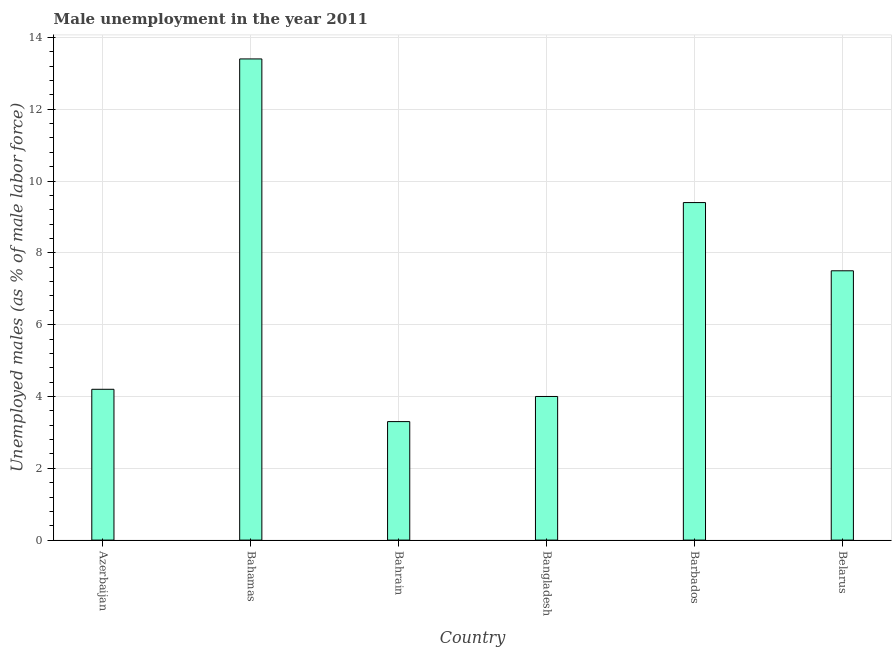What is the title of the graph?
Ensure brevity in your answer.  Male unemployment in the year 2011. What is the label or title of the X-axis?
Offer a very short reply. Country. What is the label or title of the Y-axis?
Your response must be concise. Unemployed males (as % of male labor force). What is the unemployed males population in Azerbaijan?
Keep it short and to the point. 4.2. Across all countries, what is the maximum unemployed males population?
Your response must be concise. 13.4. Across all countries, what is the minimum unemployed males population?
Provide a short and direct response. 3.3. In which country was the unemployed males population maximum?
Provide a succinct answer. Bahamas. In which country was the unemployed males population minimum?
Provide a short and direct response. Bahrain. What is the sum of the unemployed males population?
Ensure brevity in your answer.  41.8. What is the difference between the unemployed males population in Bahamas and Bangladesh?
Offer a terse response. 9.4. What is the average unemployed males population per country?
Give a very brief answer. 6.97. What is the median unemployed males population?
Give a very brief answer. 5.85. What is the ratio of the unemployed males population in Barbados to that in Belarus?
Your response must be concise. 1.25. What is the difference between the highest and the second highest unemployed males population?
Ensure brevity in your answer.  4. Are all the bars in the graph horizontal?
Provide a short and direct response. No. How many countries are there in the graph?
Offer a very short reply. 6. What is the difference between two consecutive major ticks on the Y-axis?
Your answer should be very brief. 2. What is the Unemployed males (as % of male labor force) of Azerbaijan?
Your answer should be compact. 4.2. What is the Unemployed males (as % of male labor force) in Bahamas?
Provide a succinct answer. 13.4. What is the Unemployed males (as % of male labor force) in Bahrain?
Ensure brevity in your answer.  3.3. What is the Unemployed males (as % of male labor force) of Bangladesh?
Your answer should be compact. 4. What is the Unemployed males (as % of male labor force) in Barbados?
Ensure brevity in your answer.  9.4. What is the Unemployed males (as % of male labor force) in Belarus?
Your response must be concise. 7.5. What is the difference between the Unemployed males (as % of male labor force) in Azerbaijan and Bahrain?
Provide a short and direct response. 0.9. What is the difference between the Unemployed males (as % of male labor force) in Azerbaijan and Bangladesh?
Provide a succinct answer. 0.2. What is the difference between the Unemployed males (as % of male labor force) in Bahrain and Bangladesh?
Give a very brief answer. -0.7. What is the ratio of the Unemployed males (as % of male labor force) in Azerbaijan to that in Bahamas?
Keep it short and to the point. 0.31. What is the ratio of the Unemployed males (as % of male labor force) in Azerbaijan to that in Bahrain?
Your response must be concise. 1.27. What is the ratio of the Unemployed males (as % of male labor force) in Azerbaijan to that in Bangladesh?
Make the answer very short. 1.05. What is the ratio of the Unemployed males (as % of male labor force) in Azerbaijan to that in Barbados?
Offer a very short reply. 0.45. What is the ratio of the Unemployed males (as % of male labor force) in Azerbaijan to that in Belarus?
Your answer should be very brief. 0.56. What is the ratio of the Unemployed males (as % of male labor force) in Bahamas to that in Bahrain?
Your answer should be very brief. 4.06. What is the ratio of the Unemployed males (as % of male labor force) in Bahamas to that in Bangladesh?
Your response must be concise. 3.35. What is the ratio of the Unemployed males (as % of male labor force) in Bahamas to that in Barbados?
Provide a short and direct response. 1.43. What is the ratio of the Unemployed males (as % of male labor force) in Bahamas to that in Belarus?
Offer a very short reply. 1.79. What is the ratio of the Unemployed males (as % of male labor force) in Bahrain to that in Bangladesh?
Keep it short and to the point. 0.82. What is the ratio of the Unemployed males (as % of male labor force) in Bahrain to that in Barbados?
Make the answer very short. 0.35. What is the ratio of the Unemployed males (as % of male labor force) in Bahrain to that in Belarus?
Your answer should be very brief. 0.44. What is the ratio of the Unemployed males (as % of male labor force) in Bangladesh to that in Barbados?
Provide a short and direct response. 0.43. What is the ratio of the Unemployed males (as % of male labor force) in Bangladesh to that in Belarus?
Ensure brevity in your answer.  0.53. What is the ratio of the Unemployed males (as % of male labor force) in Barbados to that in Belarus?
Offer a terse response. 1.25. 